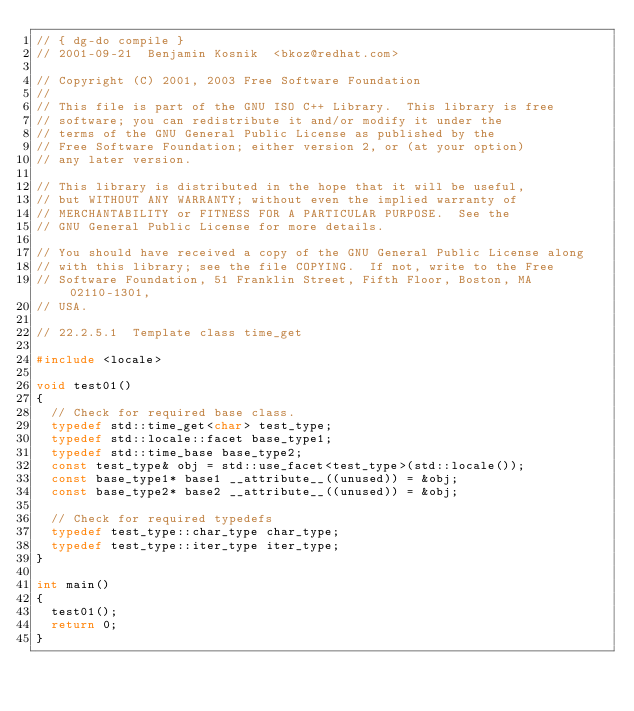<code> <loc_0><loc_0><loc_500><loc_500><_C++_>// { dg-do compile }
// 2001-09-21  Benjamin Kosnik  <bkoz@redhat.com>

// Copyright (C) 2001, 2003 Free Software Foundation
//
// This file is part of the GNU ISO C++ Library.  This library is free
// software; you can redistribute it and/or modify it under the
// terms of the GNU General Public License as published by the
// Free Software Foundation; either version 2, or (at your option)
// any later version.

// This library is distributed in the hope that it will be useful,
// but WITHOUT ANY WARRANTY; without even the implied warranty of
// MERCHANTABILITY or FITNESS FOR A PARTICULAR PURPOSE.  See the
// GNU General Public License for more details.

// You should have received a copy of the GNU General Public License along
// with this library; see the file COPYING.  If not, write to the Free
// Software Foundation, 51 Franklin Street, Fifth Floor, Boston, MA 02110-1301,
// USA.

// 22.2.5.1  Template class time_get

#include <locale>

void test01()
{
  // Check for required base class.
  typedef std::time_get<char> test_type;
  typedef std::locale::facet base_type1;
  typedef std::time_base base_type2;
  const test_type& obj = std::use_facet<test_type>(std::locale()); 
  const base_type1* base1 __attribute__((unused)) = &obj;
  const base_type2* base2 __attribute__((unused)) = &obj;
  
  // Check for required typedefs
  typedef test_type::char_type char_type;
  typedef test_type::iter_type iter_type;
}

int main()
{
  test01();
  return 0;
}
</code> 